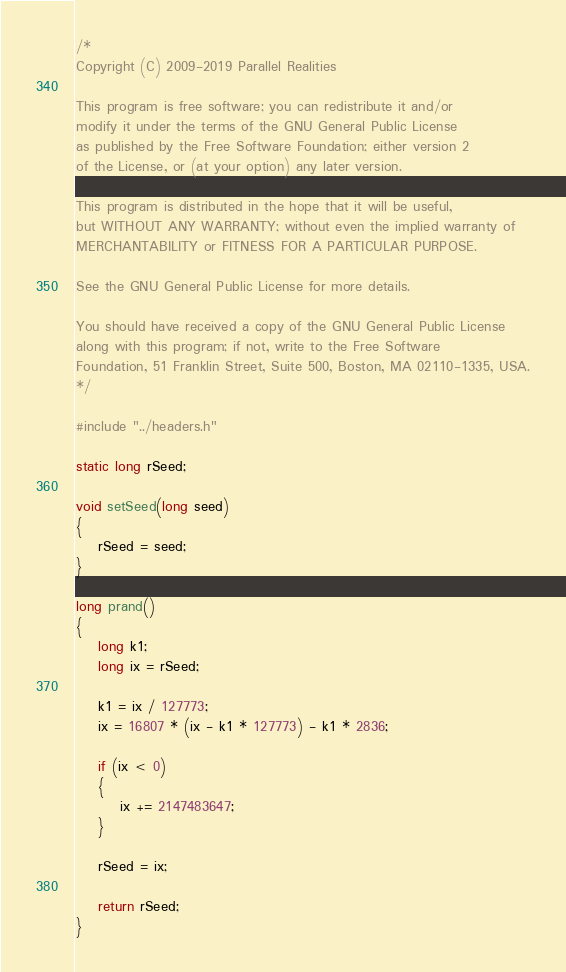Convert code to text. <code><loc_0><loc_0><loc_500><loc_500><_C_>/*
Copyright (C) 2009-2019 Parallel Realities

This program is free software; you can redistribute it and/or
modify it under the terms of the GNU General Public License
as published by the Free Software Foundation; either version 2
of the License, or (at your option) any later version.

This program is distributed in the hope that it will be useful,
but WITHOUT ANY WARRANTY; without even the implied warranty of
MERCHANTABILITY or FITNESS FOR A PARTICULAR PURPOSE.

See the GNU General Public License for more details.

You should have received a copy of the GNU General Public License
along with this program; if not, write to the Free Software
Foundation, 51 Franklin Street, Suite 500, Boston, MA 02110-1335, USA.
*/

#include "../headers.h"

static long rSeed;

void setSeed(long seed)
{
    rSeed = seed;
}

long prand()
{
    long k1;
    long ix = rSeed;

    k1 = ix / 127773;
    ix = 16807 * (ix - k1 * 127773) - k1 * 2836;

    if (ix < 0)
    {
        ix += 2147483647;
	}

    rSeed = ix;

    return rSeed;
}
</code> 